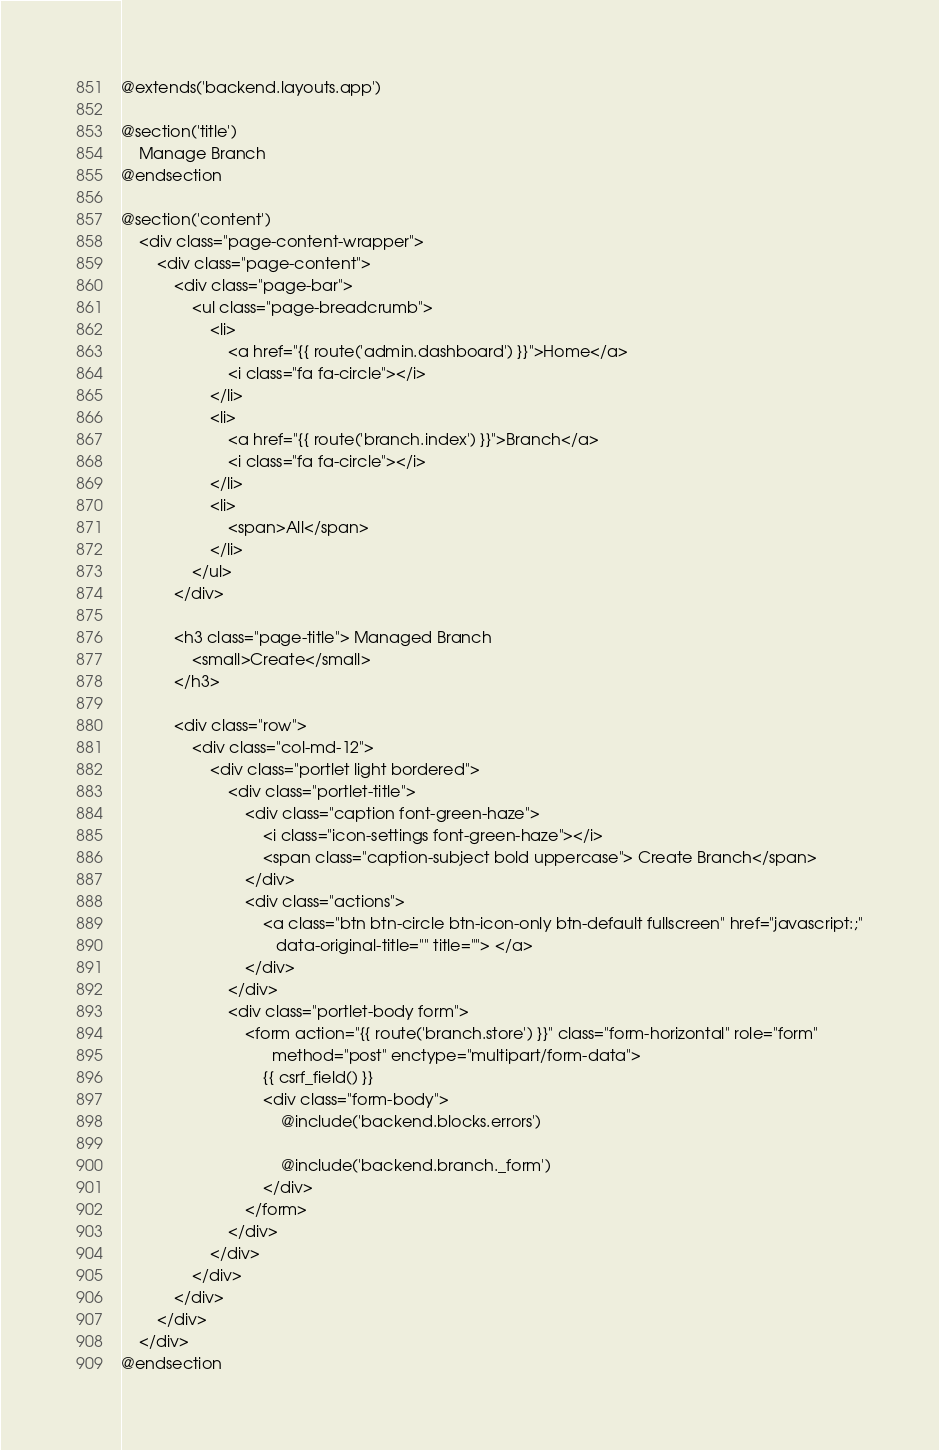Convert code to text. <code><loc_0><loc_0><loc_500><loc_500><_PHP_>@extends('backend.layouts.app')

@section('title')
    Manage Branch
@endsection

@section('content')
    <div class="page-content-wrapper">
        <div class="page-content">
            <div class="page-bar">
                <ul class="page-breadcrumb">
                    <li>
                        <a href="{{ route('admin.dashboard') }}">Home</a>
                        <i class="fa fa-circle"></i>
                    </li>
                    <li>
                        <a href="{{ route('branch.index') }}">Branch</a>
                        <i class="fa fa-circle"></i>
                    </li>
                    <li>
                        <span>All</span>
                    </li>
                </ul>
            </div>

            <h3 class="page-title"> Managed Branch
                <small>Create</small>
            </h3>

            <div class="row">
                <div class="col-md-12">
                    <div class="portlet light bordered">
                        <div class="portlet-title">
                            <div class="caption font-green-haze">
                                <i class="icon-settings font-green-haze"></i>
                                <span class="caption-subject bold uppercase"> Create Branch</span>
                            </div>
                            <div class="actions">
                                <a class="btn btn-circle btn-icon-only btn-default fullscreen" href="javascript:;"
                                   data-original-title="" title=""> </a>
                            </div>
                        </div>
                        <div class="portlet-body form">
                            <form action="{{ route('branch.store') }}" class="form-horizontal" role="form"
                                  method="post" enctype="multipart/form-data">
                                {{ csrf_field() }}
                                <div class="form-body">
                                    @include('backend.blocks.errors')

                                    @include('backend.branch._form')
                                </div>
                            </form>
                        </div>
                    </div>
                </div>
            </div>
        </div>
    </div>
@endsection</code> 